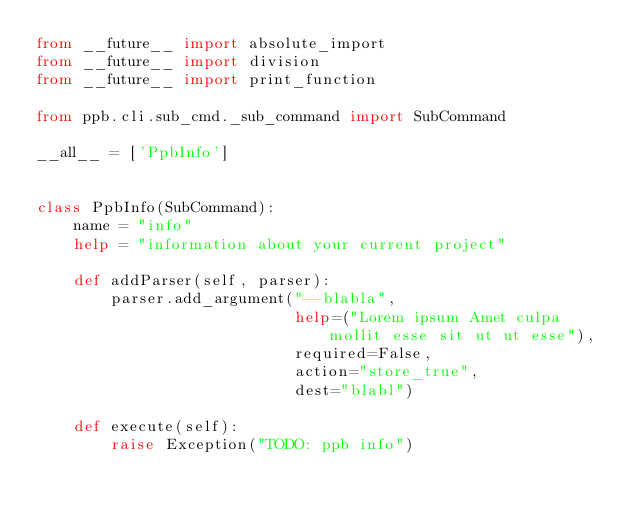Convert code to text. <code><loc_0><loc_0><loc_500><loc_500><_Python_>from __future__ import absolute_import
from __future__ import division
from __future__ import print_function

from ppb.cli.sub_cmd._sub_command import SubCommand

__all__ = ['PpbInfo']


class PpbInfo(SubCommand):
    name = "info"
    help = "information about your current project"

    def addParser(self, parser):
        parser.add_argument("--blabla",
                            help=("Lorem ipsum Amet culpa mollit esse sit ut ut esse"),
                            required=False,
                            action="store_true",
                            dest="blabl")

    def execute(self):
        raise Exception("TODO: ppb info")
</code> 